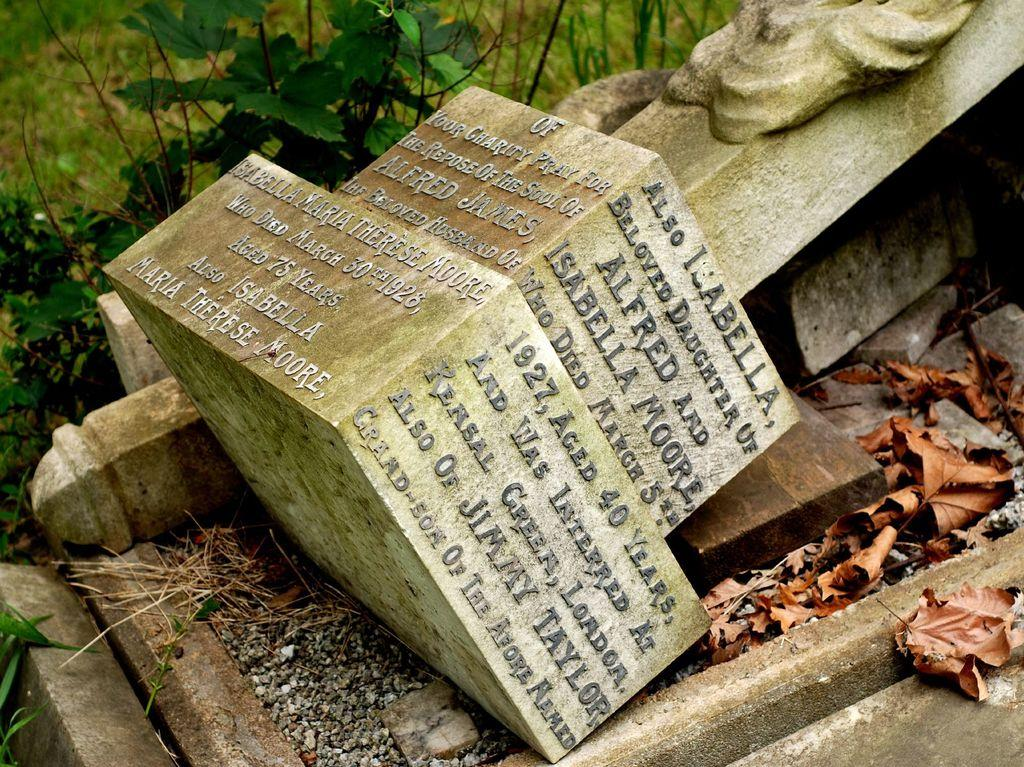What is the main subject in the center of the image? There is a statue in the center of the image. What can be seen on the right side of the image? Dry leaves are present on the right side of the image. What type of vegetation is visible at the top of the image? There are plants visible at the top of the image. What is visible beneath the statue and plants? The ground is visible in the image. How many legs does the statue have in the image? The statue does not have legs; it is a stationary object in the image. 